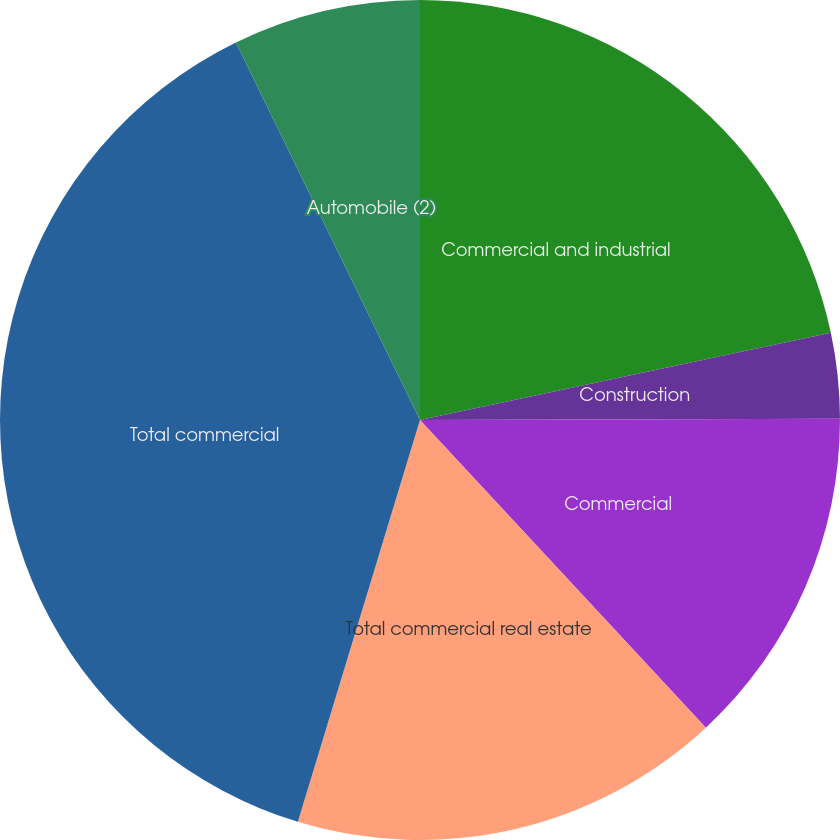Convert chart. <chart><loc_0><loc_0><loc_500><loc_500><pie_chart><fcel>Commercial and industrial<fcel>Construction<fcel>Commercial<fcel>Total commercial real estate<fcel>Total commercial<fcel>Automobile (2)<nl><fcel>21.67%<fcel>3.28%<fcel>13.13%<fcel>16.61%<fcel>38.08%<fcel>7.22%<nl></chart> 